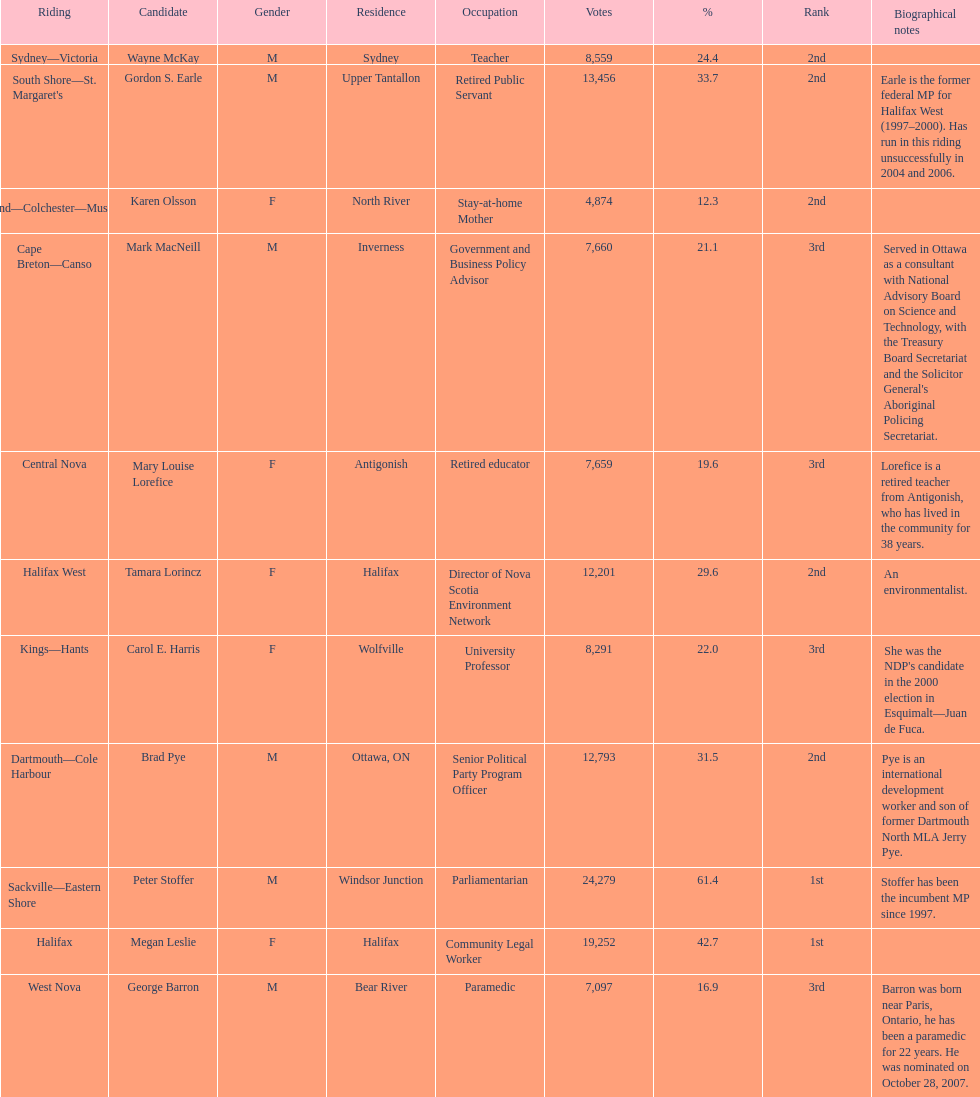Who got a larger number of votes, macneill or olsson? Mark MacNeill. 